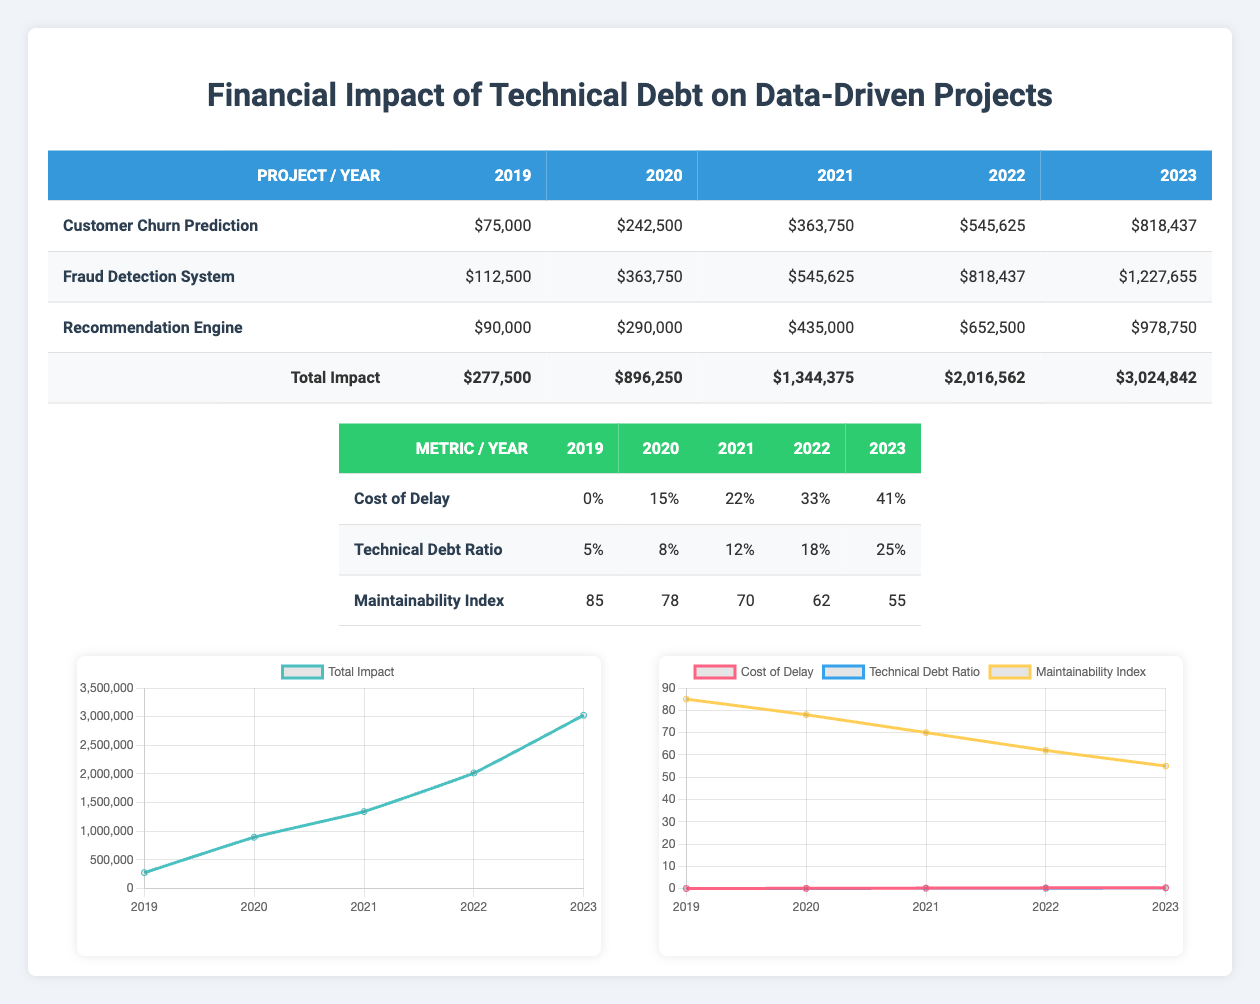What were the total annual costs for the Customer Churn Prediction project in 2020? The total annual costs in 2020 can be found by summing the figures for maintenance, refactoring, delayed features, and productivity loss for that year specifically from the 'Customer Churn Prediction' project's row. The total for 2020 is 75000 + 30000 + 100000 + 37500 = 242500.
Answer: 242500 Did the total maintenance costs increase every year from 2019 to 2023? By observing the values in the 'Total Maintenance' row for each year, we can see they are: 185000, 277500, 416250, 624375, and 936562. Each successive year has a higher value than the previous one, confirming an increase each year.
Answer: Yes What is the cumulative impact of delayed features over the five years? The cumulative impact from 'Total Delayed Features' over the five years can be determined by looking at the last year's value in the table, which for 2023 is 1248750.
Answer: 1248750 What is the percentage increase in the Technical Debt Ratio from 2020 to 2023? The Technical Debt Ratio for 2020 is 0.08 and for 2023 it is 0.25. To find the percentage increase, subtract the 2020 value from the 2023 value, divide by the 2020 value, and multiply by 100: ((0.25 - 0.08) / 0.08) * 100 = 212.5%.
Answer: 212.5% Which project had the highest cumulative impact by 2023? To identify the project with the highest cumulative impact by 2023, we evaluate the total impacts for each project at the end of the table. 'Fraud Detection System' has a cumulative impact of 1,227,655, which is the highest among the three projects listed in 2023.
Answer: Fraud Detection System What was the total productivity loss for all projects combined in 2022? The total productivity loss can be calculated by summing the productivity loss for each project in 2022. For 2022, the values are: 84375 (Customer Churn Prediction) + 126562 (Fraud Detection System) + 101250 (Recommendation Engine) = 310187.
Answer: 310187 Did the maintainability index decline every year from 2019 to 2023? By examining the values for the maintainability index over the years: 85, 78, 70, 62, and 55, we can see that each year shows a decrease from the previous year, confirming a consistent decline.
Answer: Yes What is the average cost of refactoring across all projects in 2021? The refactoring costs for each project in 2021 are 45000 (Customer Churn Prediction) + 67500 (Fraud Detection System) + 52500 (Recommendation Engine) = 165000. To find the average, we divide by the number of projects: 165000 / 3 = 55000.
Answer: 55000 